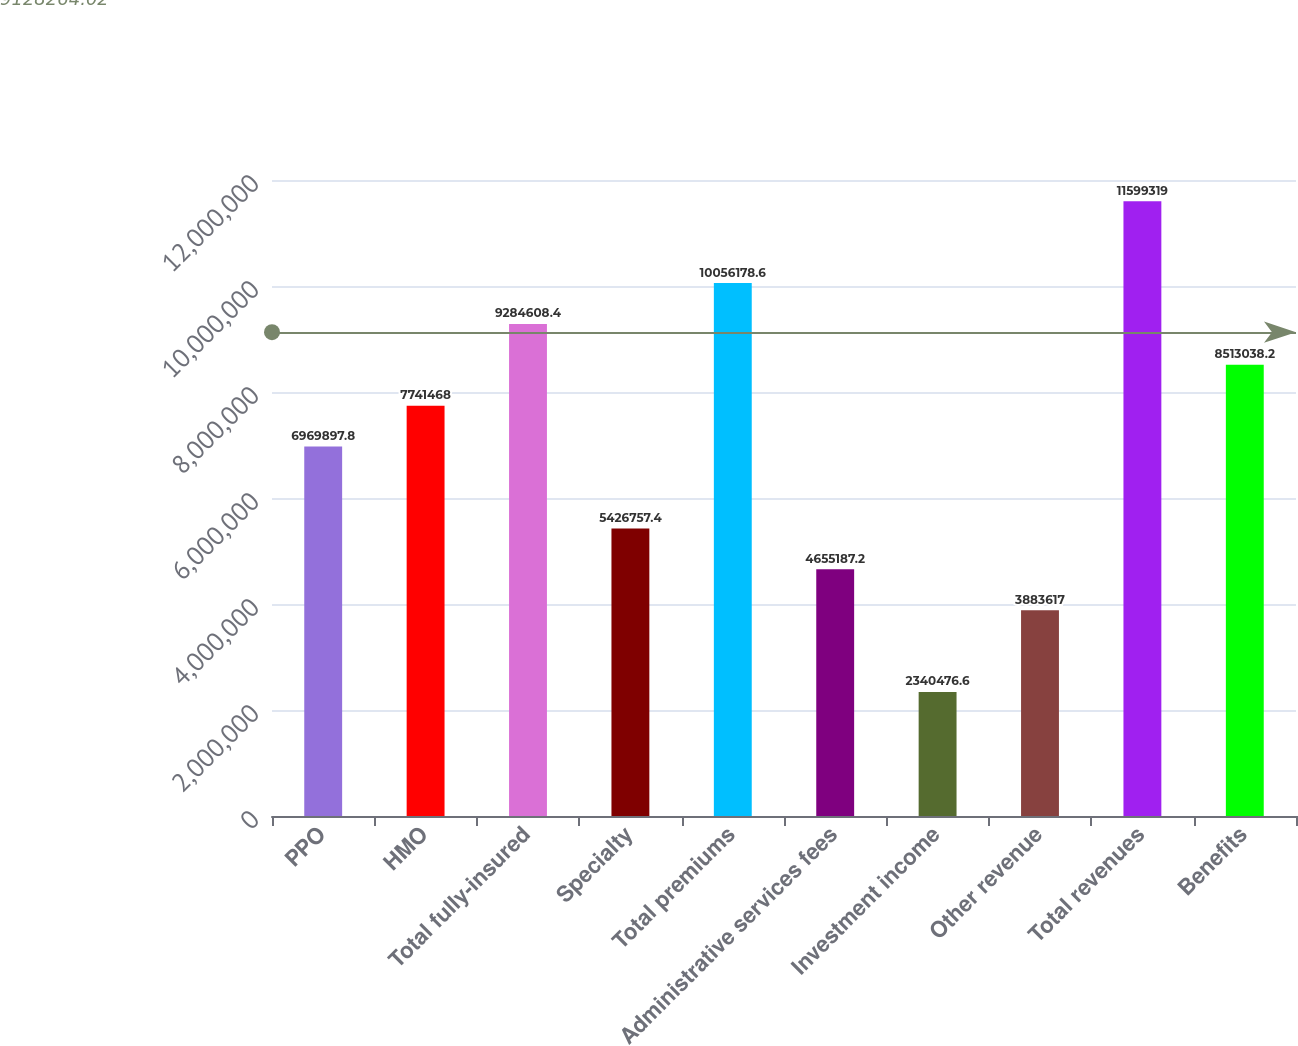<chart> <loc_0><loc_0><loc_500><loc_500><bar_chart><fcel>PPO<fcel>HMO<fcel>Total fully-insured<fcel>Specialty<fcel>Total premiums<fcel>Administrative services fees<fcel>Investment income<fcel>Other revenue<fcel>Total revenues<fcel>Benefits<nl><fcel>6.9699e+06<fcel>7.74147e+06<fcel>9.28461e+06<fcel>5.42676e+06<fcel>1.00562e+07<fcel>4.65519e+06<fcel>2.34048e+06<fcel>3.88362e+06<fcel>1.15993e+07<fcel>8.51304e+06<nl></chart> 